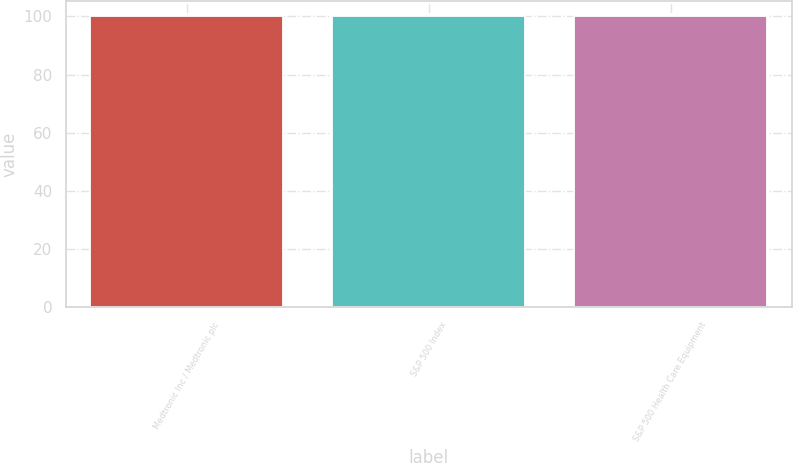Convert chart. <chart><loc_0><loc_0><loc_500><loc_500><bar_chart><fcel>Medtronic Inc / Medtronic plc<fcel>S&P 500 Index<fcel>S&P 500 Health Care Equipment<nl><fcel>100<fcel>100.1<fcel>100.2<nl></chart> 